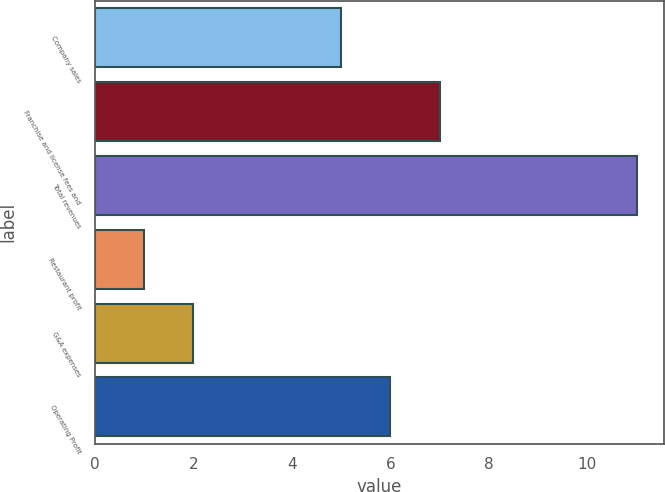<chart> <loc_0><loc_0><loc_500><loc_500><bar_chart><fcel>Company sales<fcel>Franchise and license fees and<fcel>Total revenues<fcel>Restaurant profit<fcel>G&A expenses<fcel>Operating Profit<nl><fcel>5<fcel>7<fcel>11<fcel>1<fcel>2<fcel>6<nl></chart> 